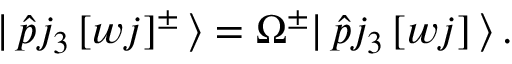<formula> <loc_0><loc_0><loc_500><loc_500>| \, \hat { p } j _ { 3 } \, [ w j ] ^ { \pm } \, \rangle = \Omega ^ { \pm } | \, \hat { p } j _ { 3 } \, [ w j ] \, \rangle \, .</formula> 